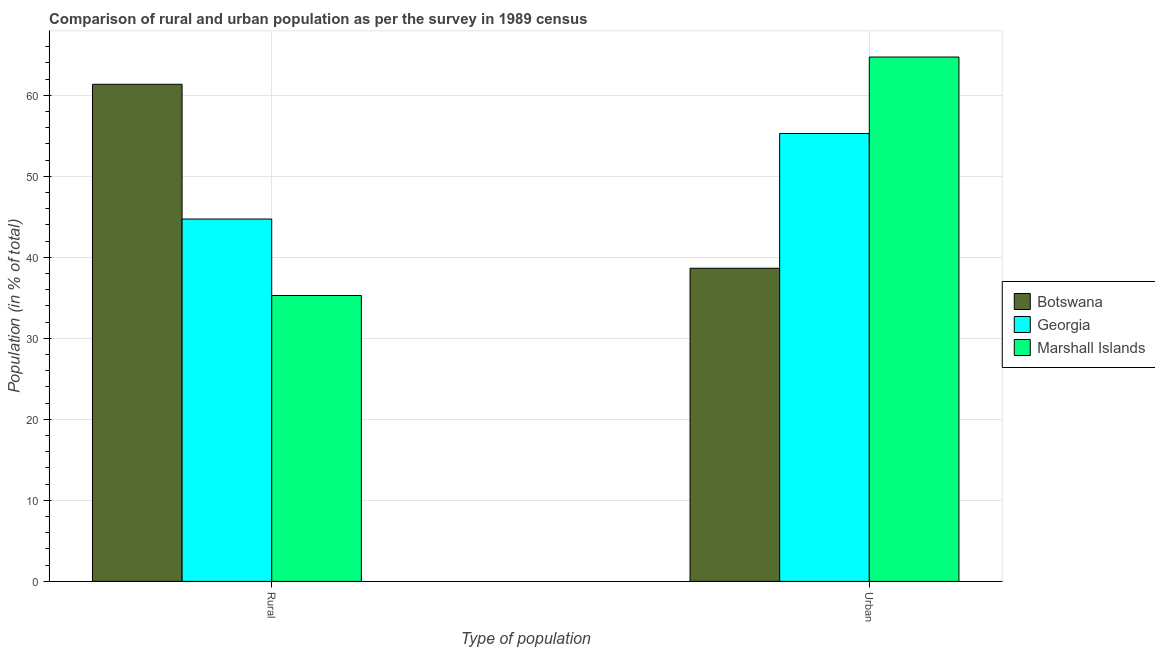How many different coloured bars are there?
Give a very brief answer. 3. How many groups of bars are there?
Offer a terse response. 2. Are the number of bars per tick equal to the number of legend labels?
Provide a short and direct response. Yes. Are the number of bars on each tick of the X-axis equal?
Provide a succinct answer. Yes. What is the label of the 2nd group of bars from the left?
Keep it short and to the point. Urban. What is the rural population in Marshall Islands?
Keep it short and to the point. 35.29. Across all countries, what is the maximum rural population?
Your response must be concise. 61.35. Across all countries, what is the minimum rural population?
Give a very brief answer. 35.29. In which country was the urban population maximum?
Provide a succinct answer. Marshall Islands. In which country was the rural population minimum?
Ensure brevity in your answer.  Marshall Islands. What is the total rural population in the graph?
Make the answer very short. 141.36. What is the difference between the urban population in Botswana and that in Marshall Islands?
Keep it short and to the point. -26.07. What is the difference between the urban population in Botswana and the rural population in Marshall Islands?
Ensure brevity in your answer.  3.36. What is the average rural population per country?
Give a very brief answer. 47.12. What is the difference between the rural population and urban population in Georgia?
Make the answer very short. -10.55. What is the ratio of the rural population in Botswana to that in Georgia?
Your answer should be very brief. 1.37. In how many countries, is the rural population greater than the average rural population taken over all countries?
Offer a terse response. 1. What does the 3rd bar from the left in Rural represents?
Your answer should be compact. Marshall Islands. What does the 3rd bar from the right in Urban represents?
Make the answer very short. Botswana. What is the difference between two consecutive major ticks on the Y-axis?
Keep it short and to the point. 10. Are the values on the major ticks of Y-axis written in scientific E-notation?
Offer a terse response. No. Does the graph contain grids?
Ensure brevity in your answer.  Yes. Where does the legend appear in the graph?
Your answer should be very brief. Center right. How many legend labels are there?
Offer a terse response. 3. How are the legend labels stacked?
Provide a short and direct response. Vertical. What is the title of the graph?
Provide a succinct answer. Comparison of rural and urban population as per the survey in 1989 census. Does "Bulgaria" appear as one of the legend labels in the graph?
Your answer should be very brief. No. What is the label or title of the X-axis?
Your response must be concise. Type of population. What is the label or title of the Y-axis?
Offer a very short reply. Population (in % of total). What is the Population (in % of total) in Botswana in Rural?
Your answer should be compact. 61.35. What is the Population (in % of total) in Georgia in Rural?
Your answer should be very brief. 44.72. What is the Population (in % of total) in Marshall Islands in Rural?
Offer a terse response. 35.29. What is the Population (in % of total) in Botswana in Urban?
Make the answer very short. 38.65. What is the Population (in % of total) in Georgia in Urban?
Offer a terse response. 55.28. What is the Population (in % of total) of Marshall Islands in Urban?
Offer a very short reply. 64.71. Across all Type of population, what is the maximum Population (in % of total) in Botswana?
Ensure brevity in your answer.  61.35. Across all Type of population, what is the maximum Population (in % of total) in Georgia?
Provide a short and direct response. 55.28. Across all Type of population, what is the maximum Population (in % of total) in Marshall Islands?
Offer a very short reply. 64.71. Across all Type of population, what is the minimum Population (in % of total) of Botswana?
Keep it short and to the point. 38.65. Across all Type of population, what is the minimum Population (in % of total) in Georgia?
Your answer should be very brief. 44.72. Across all Type of population, what is the minimum Population (in % of total) in Marshall Islands?
Give a very brief answer. 35.29. What is the total Population (in % of total) in Botswana in the graph?
Keep it short and to the point. 100. What is the total Population (in % of total) in Marshall Islands in the graph?
Keep it short and to the point. 100. What is the difference between the Population (in % of total) in Botswana in Rural and that in Urban?
Your response must be concise. 22.7. What is the difference between the Population (in % of total) in Georgia in Rural and that in Urban?
Give a very brief answer. -10.55. What is the difference between the Population (in % of total) of Marshall Islands in Rural and that in Urban?
Offer a terse response. -29.43. What is the difference between the Population (in % of total) of Botswana in Rural and the Population (in % of total) of Georgia in Urban?
Provide a short and direct response. 6.08. What is the difference between the Population (in % of total) in Botswana in Rural and the Population (in % of total) in Marshall Islands in Urban?
Your answer should be very brief. -3.36. What is the difference between the Population (in % of total) of Georgia in Rural and the Population (in % of total) of Marshall Islands in Urban?
Provide a short and direct response. -19.99. What is the average Population (in % of total) of Botswana per Type of population?
Your answer should be very brief. 50. What is the difference between the Population (in % of total) of Botswana and Population (in % of total) of Georgia in Rural?
Keep it short and to the point. 16.63. What is the difference between the Population (in % of total) in Botswana and Population (in % of total) in Marshall Islands in Rural?
Provide a short and direct response. 26.07. What is the difference between the Population (in % of total) of Georgia and Population (in % of total) of Marshall Islands in Rural?
Your response must be concise. 9.44. What is the difference between the Population (in % of total) in Botswana and Population (in % of total) in Georgia in Urban?
Provide a short and direct response. -16.63. What is the difference between the Population (in % of total) of Botswana and Population (in % of total) of Marshall Islands in Urban?
Your answer should be very brief. -26.07. What is the difference between the Population (in % of total) of Georgia and Population (in % of total) of Marshall Islands in Urban?
Offer a very short reply. -9.44. What is the ratio of the Population (in % of total) of Botswana in Rural to that in Urban?
Your answer should be compact. 1.59. What is the ratio of the Population (in % of total) in Georgia in Rural to that in Urban?
Give a very brief answer. 0.81. What is the ratio of the Population (in % of total) in Marshall Islands in Rural to that in Urban?
Make the answer very short. 0.55. What is the difference between the highest and the second highest Population (in % of total) in Botswana?
Your answer should be compact. 22.7. What is the difference between the highest and the second highest Population (in % of total) of Georgia?
Keep it short and to the point. 10.55. What is the difference between the highest and the second highest Population (in % of total) of Marshall Islands?
Offer a very short reply. 29.43. What is the difference between the highest and the lowest Population (in % of total) in Botswana?
Provide a short and direct response. 22.7. What is the difference between the highest and the lowest Population (in % of total) in Georgia?
Make the answer very short. 10.55. What is the difference between the highest and the lowest Population (in % of total) of Marshall Islands?
Offer a terse response. 29.43. 